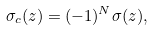Convert formula to latex. <formula><loc_0><loc_0><loc_500><loc_500>\sigma _ { c } ( z ) = ( - 1 ) ^ { N } \sigma ( z ) ,</formula> 